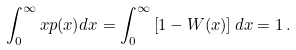<formula> <loc_0><loc_0><loc_500><loc_500>\int _ { 0 } ^ { \infty } x p ( x ) d x = \int _ { 0 } ^ { \infty } \left [ 1 - W ( x ) \right ] d x = 1 \, .</formula> 